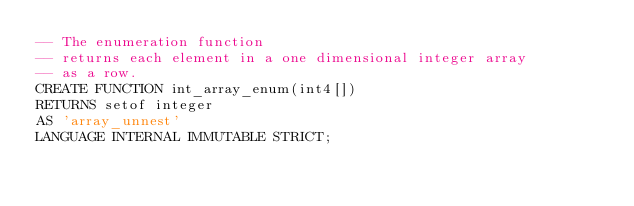Convert code to text. <code><loc_0><loc_0><loc_500><loc_500><_SQL_>-- The enumeration function
-- returns each element in a one dimensional integer array
-- as a row.
CREATE FUNCTION int_array_enum(int4[])
RETURNS setof integer
AS 'array_unnest'
LANGUAGE INTERNAL IMMUTABLE STRICT;
</code> 